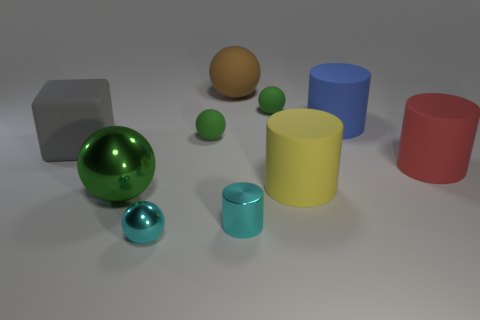How many green spheres must be subtracted to get 1 green spheres? 2 Subtract all green blocks. How many green spheres are left? 3 Subtract all large red matte cylinders. How many cylinders are left? 3 Subtract all cyan cylinders. How many cylinders are left? 3 Subtract all cubes. How many objects are left? 9 Add 4 metallic spheres. How many metallic spheres are left? 6 Add 8 large green metal objects. How many large green metal objects exist? 9 Subtract 1 red cylinders. How many objects are left? 9 Subtract all yellow cylinders. Subtract all cyan balls. How many cylinders are left? 3 Subtract all big green objects. Subtract all metal things. How many objects are left? 6 